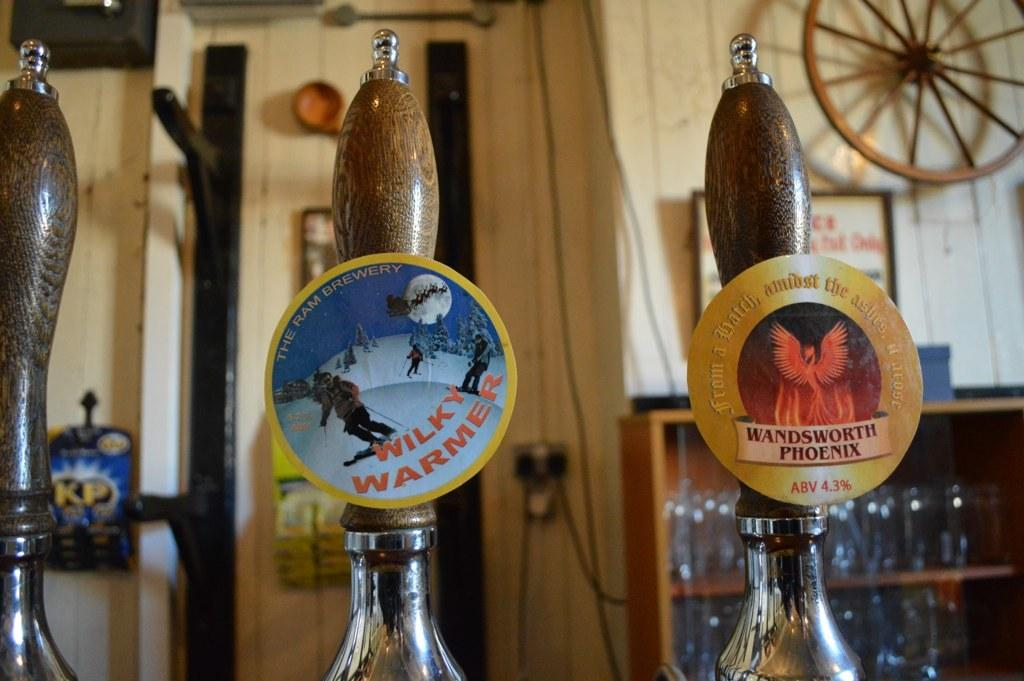<image>
Write a terse but informative summary of the picture. beer taps next to each other with one of them labeled as 'wilky warmer' 